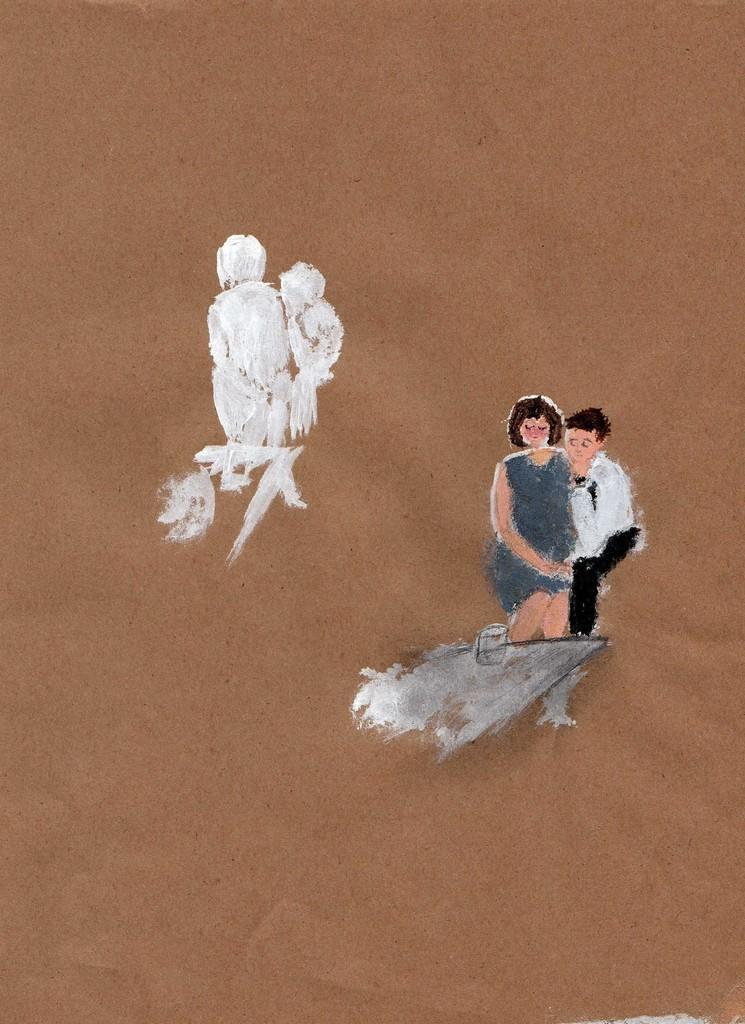What type of artwork is depicted in the image? The image appears to be a painting. Can you describe the subjects in the painting? There is a man and a woman on the right side of the image. What type of bait is being used by the man in the painting? There is no bait present in the image, as it is a painting of a man and a woman. 